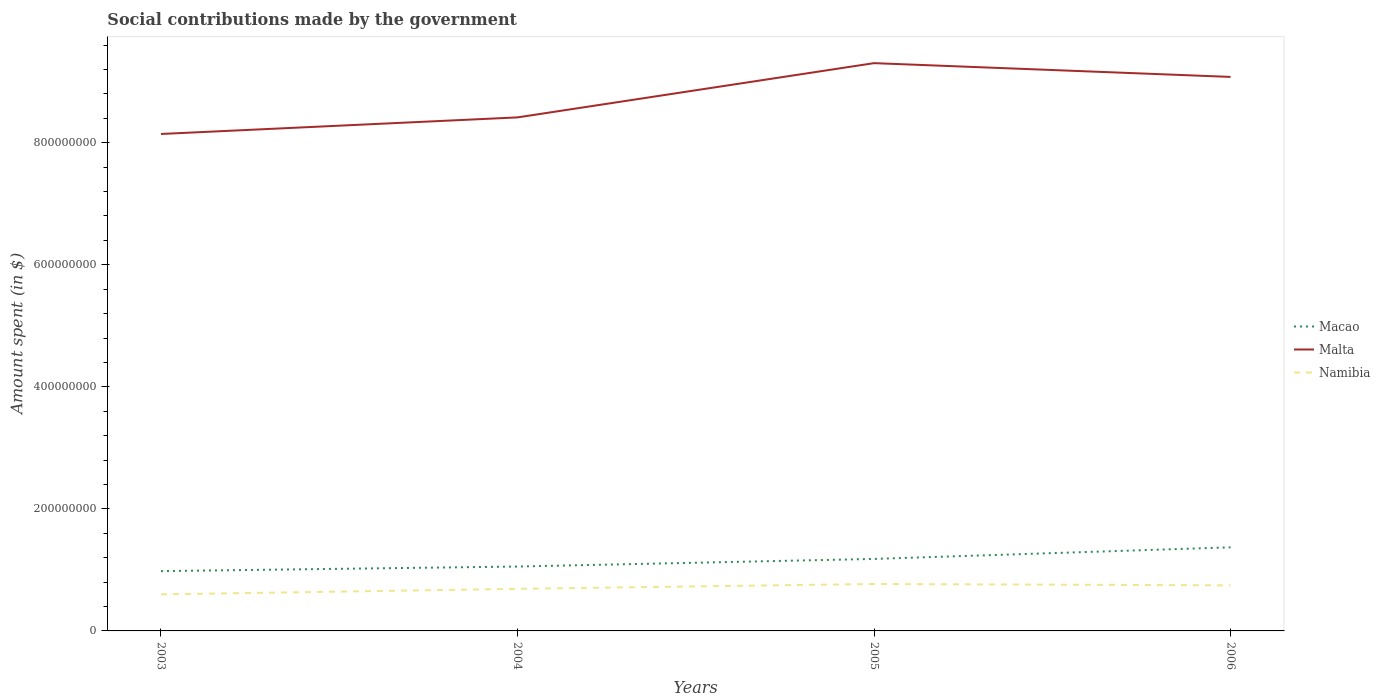Is the number of lines equal to the number of legend labels?
Make the answer very short. Yes. Across all years, what is the maximum amount spent on social contributions in Malta?
Give a very brief answer. 8.14e+08. What is the total amount spent on social contributions in Namibia in the graph?
Make the answer very short. -7.95e+06. What is the difference between the highest and the second highest amount spent on social contributions in Macao?
Provide a short and direct response. 3.90e+07. Is the amount spent on social contributions in Namibia strictly greater than the amount spent on social contributions in Macao over the years?
Provide a short and direct response. Yes. How many lines are there?
Ensure brevity in your answer.  3. How many years are there in the graph?
Keep it short and to the point. 4. Does the graph contain any zero values?
Offer a very short reply. No. How many legend labels are there?
Provide a short and direct response. 3. What is the title of the graph?
Your response must be concise. Social contributions made by the government. What is the label or title of the Y-axis?
Keep it short and to the point. Amount spent (in $). What is the Amount spent (in $) in Macao in 2003?
Keep it short and to the point. 9.80e+07. What is the Amount spent (in $) in Malta in 2003?
Keep it short and to the point. 8.14e+08. What is the Amount spent (in $) in Namibia in 2003?
Your response must be concise. 5.99e+07. What is the Amount spent (in $) in Macao in 2004?
Provide a short and direct response. 1.06e+08. What is the Amount spent (in $) in Malta in 2004?
Offer a terse response. 8.42e+08. What is the Amount spent (in $) of Namibia in 2004?
Your answer should be very brief. 6.90e+07. What is the Amount spent (in $) in Macao in 2005?
Ensure brevity in your answer.  1.18e+08. What is the Amount spent (in $) of Malta in 2005?
Your answer should be compact. 9.30e+08. What is the Amount spent (in $) in Namibia in 2005?
Offer a very short reply. 7.69e+07. What is the Amount spent (in $) of Macao in 2006?
Provide a succinct answer. 1.37e+08. What is the Amount spent (in $) of Malta in 2006?
Make the answer very short. 9.08e+08. What is the Amount spent (in $) of Namibia in 2006?
Provide a short and direct response. 7.47e+07. Across all years, what is the maximum Amount spent (in $) of Macao?
Provide a succinct answer. 1.37e+08. Across all years, what is the maximum Amount spent (in $) of Malta?
Give a very brief answer. 9.30e+08. Across all years, what is the maximum Amount spent (in $) of Namibia?
Offer a very short reply. 7.69e+07. Across all years, what is the minimum Amount spent (in $) in Macao?
Your response must be concise. 9.80e+07. Across all years, what is the minimum Amount spent (in $) in Malta?
Provide a short and direct response. 8.14e+08. Across all years, what is the minimum Amount spent (in $) in Namibia?
Give a very brief answer. 5.99e+07. What is the total Amount spent (in $) of Macao in the graph?
Offer a terse response. 4.59e+08. What is the total Amount spent (in $) of Malta in the graph?
Ensure brevity in your answer.  3.49e+09. What is the total Amount spent (in $) in Namibia in the graph?
Provide a succinct answer. 2.80e+08. What is the difference between the Amount spent (in $) of Macao in 2003 and that in 2004?
Ensure brevity in your answer.  -7.49e+06. What is the difference between the Amount spent (in $) of Malta in 2003 and that in 2004?
Your response must be concise. -2.72e+07. What is the difference between the Amount spent (in $) of Namibia in 2003 and that in 2004?
Offer a terse response. -9.08e+06. What is the difference between the Amount spent (in $) of Macao in 2003 and that in 2005?
Your answer should be compact. -2.00e+07. What is the difference between the Amount spent (in $) of Malta in 2003 and that in 2005?
Your answer should be very brief. -1.16e+08. What is the difference between the Amount spent (in $) of Namibia in 2003 and that in 2005?
Provide a short and direct response. -1.70e+07. What is the difference between the Amount spent (in $) of Macao in 2003 and that in 2006?
Your response must be concise. -3.90e+07. What is the difference between the Amount spent (in $) of Malta in 2003 and that in 2006?
Your answer should be compact. -9.35e+07. What is the difference between the Amount spent (in $) of Namibia in 2003 and that in 2006?
Make the answer very short. -1.48e+07. What is the difference between the Amount spent (in $) of Macao in 2004 and that in 2005?
Make the answer very short. -1.25e+07. What is the difference between the Amount spent (in $) of Malta in 2004 and that in 2005?
Provide a short and direct response. -8.89e+07. What is the difference between the Amount spent (in $) in Namibia in 2004 and that in 2005?
Make the answer very short. -7.95e+06. What is the difference between the Amount spent (in $) in Macao in 2004 and that in 2006?
Your answer should be very brief. -3.15e+07. What is the difference between the Amount spent (in $) in Malta in 2004 and that in 2006?
Your answer should be very brief. -6.64e+07. What is the difference between the Amount spent (in $) of Namibia in 2004 and that in 2006?
Give a very brief answer. -5.71e+06. What is the difference between the Amount spent (in $) of Macao in 2005 and that in 2006?
Offer a very short reply. -1.90e+07. What is the difference between the Amount spent (in $) of Malta in 2005 and that in 2006?
Ensure brevity in your answer.  2.26e+07. What is the difference between the Amount spent (in $) in Namibia in 2005 and that in 2006?
Your response must be concise. 2.24e+06. What is the difference between the Amount spent (in $) of Macao in 2003 and the Amount spent (in $) of Malta in 2004?
Keep it short and to the point. -7.44e+08. What is the difference between the Amount spent (in $) of Macao in 2003 and the Amount spent (in $) of Namibia in 2004?
Provide a short and direct response. 2.91e+07. What is the difference between the Amount spent (in $) in Malta in 2003 and the Amount spent (in $) in Namibia in 2004?
Your answer should be very brief. 7.45e+08. What is the difference between the Amount spent (in $) in Macao in 2003 and the Amount spent (in $) in Malta in 2005?
Your answer should be very brief. -8.32e+08. What is the difference between the Amount spent (in $) of Macao in 2003 and the Amount spent (in $) of Namibia in 2005?
Offer a very short reply. 2.11e+07. What is the difference between the Amount spent (in $) in Malta in 2003 and the Amount spent (in $) in Namibia in 2005?
Make the answer very short. 7.37e+08. What is the difference between the Amount spent (in $) in Macao in 2003 and the Amount spent (in $) in Malta in 2006?
Make the answer very short. -8.10e+08. What is the difference between the Amount spent (in $) in Macao in 2003 and the Amount spent (in $) in Namibia in 2006?
Offer a terse response. 2.34e+07. What is the difference between the Amount spent (in $) in Malta in 2003 and the Amount spent (in $) in Namibia in 2006?
Make the answer very short. 7.40e+08. What is the difference between the Amount spent (in $) in Macao in 2004 and the Amount spent (in $) in Malta in 2005?
Make the answer very short. -8.25e+08. What is the difference between the Amount spent (in $) in Macao in 2004 and the Amount spent (in $) in Namibia in 2005?
Provide a succinct answer. 2.86e+07. What is the difference between the Amount spent (in $) in Malta in 2004 and the Amount spent (in $) in Namibia in 2005?
Give a very brief answer. 7.65e+08. What is the difference between the Amount spent (in $) in Macao in 2004 and the Amount spent (in $) in Malta in 2006?
Your answer should be compact. -8.02e+08. What is the difference between the Amount spent (in $) in Macao in 2004 and the Amount spent (in $) in Namibia in 2006?
Ensure brevity in your answer.  3.08e+07. What is the difference between the Amount spent (in $) in Malta in 2004 and the Amount spent (in $) in Namibia in 2006?
Provide a succinct answer. 7.67e+08. What is the difference between the Amount spent (in $) of Macao in 2005 and the Amount spent (in $) of Malta in 2006?
Ensure brevity in your answer.  -7.90e+08. What is the difference between the Amount spent (in $) of Macao in 2005 and the Amount spent (in $) of Namibia in 2006?
Ensure brevity in your answer.  4.33e+07. What is the difference between the Amount spent (in $) of Malta in 2005 and the Amount spent (in $) of Namibia in 2006?
Offer a terse response. 8.56e+08. What is the average Amount spent (in $) of Macao per year?
Provide a short and direct response. 1.15e+08. What is the average Amount spent (in $) of Malta per year?
Offer a very short reply. 8.74e+08. What is the average Amount spent (in $) in Namibia per year?
Provide a short and direct response. 7.01e+07. In the year 2003, what is the difference between the Amount spent (in $) in Macao and Amount spent (in $) in Malta?
Your answer should be compact. -7.16e+08. In the year 2003, what is the difference between the Amount spent (in $) of Macao and Amount spent (in $) of Namibia?
Provide a short and direct response. 3.81e+07. In the year 2003, what is the difference between the Amount spent (in $) in Malta and Amount spent (in $) in Namibia?
Make the answer very short. 7.55e+08. In the year 2004, what is the difference between the Amount spent (in $) of Macao and Amount spent (in $) of Malta?
Offer a terse response. -7.36e+08. In the year 2004, what is the difference between the Amount spent (in $) in Macao and Amount spent (in $) in Namibia?
Offer a very short reply. 3.65e+07. In the year 2004, what is the difference between the Amount spent (in $) of Malta and Amount spent (in $) of Namibia?
Your response must be concise. 7.73e+08. In the year 2005, what is the difference between the Amount spent (in $) of Macao and Amount spent (in $) of Malta?
Make the answer very short. -8.12e+08. In the year 2005, what is the difference between the Amount spent (in $) in Macao and Amount spent (in $) in Namibia?
Keep it short and to the point. 4.11e+07. In the year 2005, what is the difference between the Amount spent (in $) in Malta and Amount spent (in $) in Namibia?
Offer a terse response. 8.54e+08. In the year 2006, what is the difference between the Amount spent (in $) in Macao and Amount spent (in $) in Malta?
Give a very brief answer. -7.71e+08. In the year 2006, what is the difference between the Amount spent (in $) of Macao and Amount spent (in $) of Namibia?
Offer a terse response. 6.23e+07. In the year 2006, what is the difference between the Amount spent (in $) in Malta and Amount spent (in $) in Namibia?
Give a very brief answer. 8.33e+08. What is the ratio of the Amount spent (in $) of Macao in 2003 to that in 2004?
Offer a very short reply. 0.93. What is the ratio of the Amount spent (in $) in Namibia in 2003 to that in 2004?
Offer a terse response. 0.87. What is the ratio of the Amount spent (in $) of Macao in 2003 to that in 2005?
Give a very brief answer. 0.83. What is the ratio of the Amount spent (in $) in Malta in 2003 to that in 2005?
Your answer should be very brief. 0.88. What is the ratio of the Amount spent (in $) of Namibia in 2003 to that in 2005?
Make the answer very short. 0.78. What is the ratio of the Amount spent (in $) of Macao in 2003 to that in 2006?
Ensure brevity in your answer.  0.72. What is the ratio of the Amount spent (in $) of Malta in 2003 to that in 2006?
Your answer should be compact. 0.9. What is the ratio of the Amount spent (in $) in Namibia in 2003 to that in 2006?
Provide a succinct answer. 0.8. What is the ratio of the Amount spent (in $) in Macao in 2004 to that in 2005?
Ensure brevity in your answer.  0.89. What is the ratio of the Amount spent (in $) of Malta in 2004 to that in 2005?
Offer a very short reply. 0.9. What is the ratio of the Amount spent (in $) of Namibia in 2004 to that in 2005?
Make the answer very short. 0.9. What is the ratio of the Amount spent (in $) of Macao in 2004 to that in 2006?
Ensure brevity in your answer.  0.77. What is the ratio of the Amount spent (in $) of Malta in 2004 to that in 2006?
Provide a short and direct response. 0.93. What is the ratio of the Amount spent (in $) of Namibia in 2004 to that in 2006?
Make the answer very short. 0.92. What is the ratio of the Amount spent (in $) in Macao in 2005 to that in 2006?
Provide a short and direct response. 0.86. What is the ratio of the Amount spent (in $) of Malta in 2005 to that in 2006?
Your response must be concise. 1.02. What is the difference between the highest and the second highest Amount spent (in $) in Macao?
Your answer should be compact. 1.90e+07. What is the difference between the highest and the second highest Amount spent (in $) of Malta?
Make the answer very short. 2.26e+07. What is the difference between the highest and the second highest Amount spent (in $) of Namibia?
Your answer should be very brief. 2.24e+06. What is the difference between the highest and the lowest Amount spent (in $) of Macao?
Provide a succinct answer. 3.90e+07. What is the difference between the highest and the lowest Amount spent (in $) in Malta?
Your answer should be compact. 1.16e+08. What is the difference between the highest and the lowest Amount spent (in $) in Namibia?
Ensure brevity in your answer.  1.70e+07. 